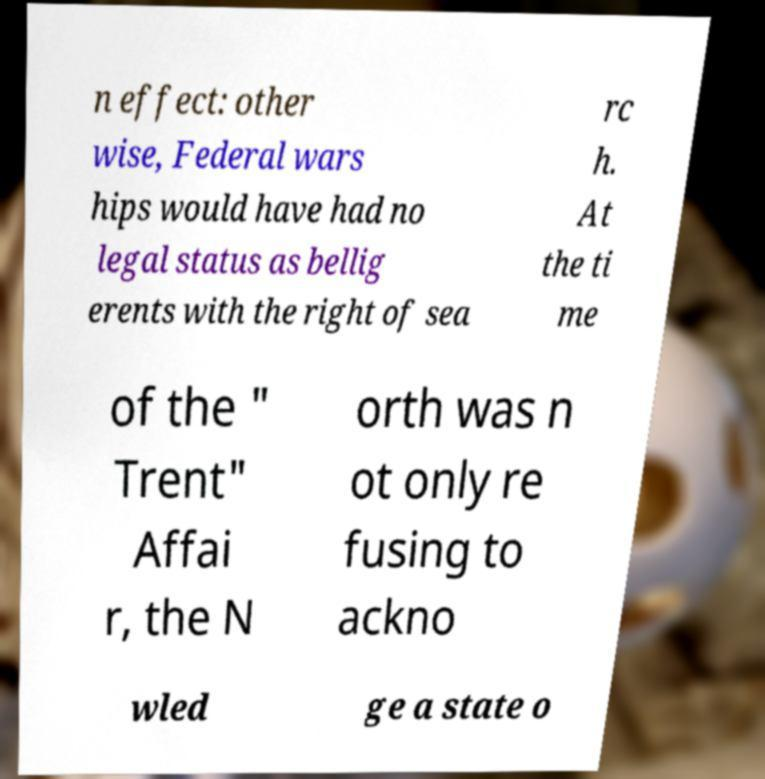There's text embedded in this image that I need extracted. Can you transcribe it verbatim? n effect: other wise, Federal wars hips would have had no legal status as bellig erents with the right of sea rc h. At the ti me of the " Trent" Affai r, the N orth was n ot only re fusing to ackno wled ge a state o 